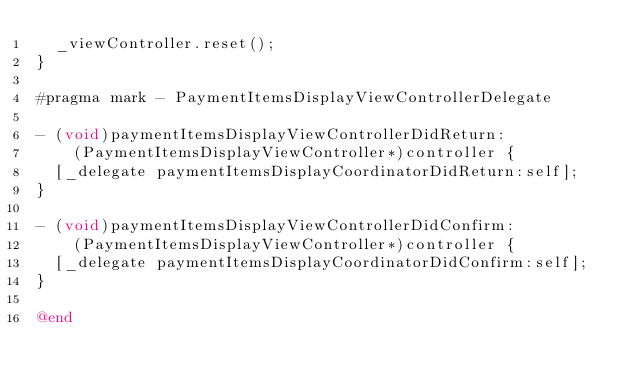<code> <loc_0><loc_0><loc_500><loc_500><_ObjectiveC_>  _viewController.reset();
}

#pragma mark - PaymentItemsDisplayViewControllerDelegate

- (void)paymentItemsDisplayViewControllerDidReturn:
    (PaymentItemsDisplayViewController*)controller {
  [_delegate paymentItemsDisplayCoordinatorDidReturn:self];
}

- (void)paymentItemsDisplayViewControllerDidConfirm:
    (PaymentItemsDisplayViewController*)controller {
  [_delegate paymentItemsDisplayCoordinatorDidConfirm:self];
}

@end
</code> 